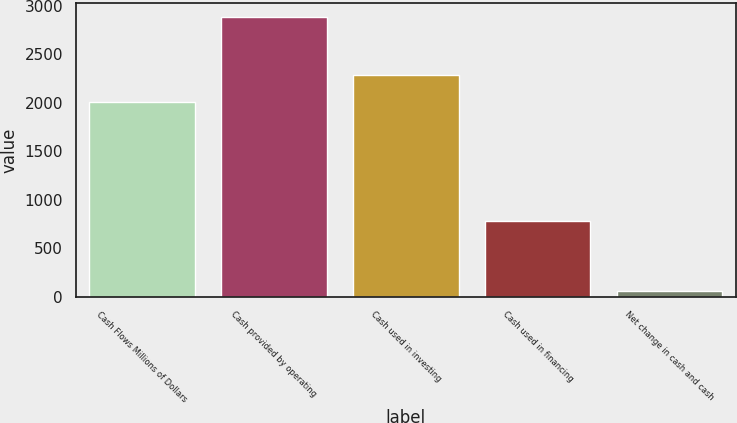Convert chart. <chart><loc_0><loc_0><loc_500><loc_500><bar_chart><fcel>Cash Flows Millions of Dollars<fcel>Cash provided by operating<fcel>Cash used in investing<fcel>Cash used in financing<fcel>Net change in cash and cash<nl><fcel>2006<fcel>2880<fcel>2288.6<fcel>784<fcel>54<nl></chart> 